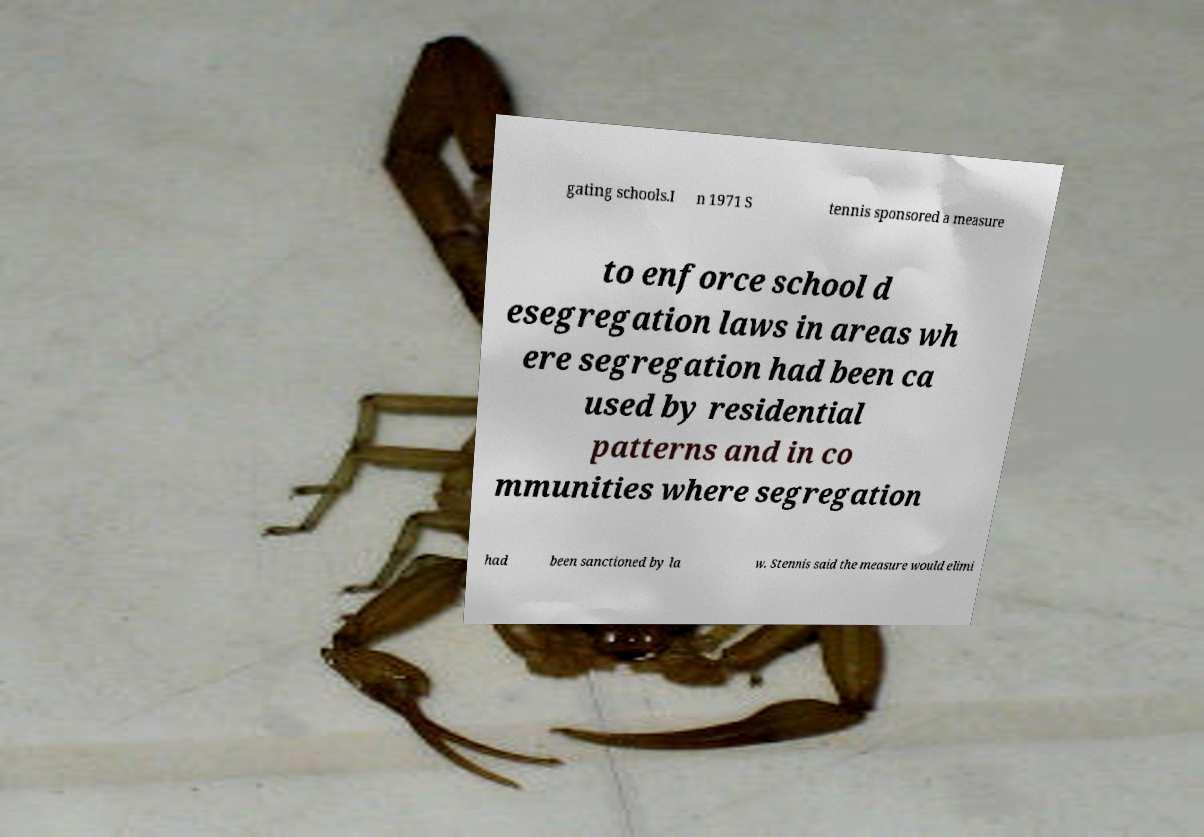Can you accurately transcribe the text from the provided image for me? gating schools.I n 1971 S tennis sponsored a measure to enforce school d esegregation laws in areas wh ere segregation had been ca used by residential patterns and in co mmunities where segregation had been sanctioned by la w. Stennis said the measure would elimi 